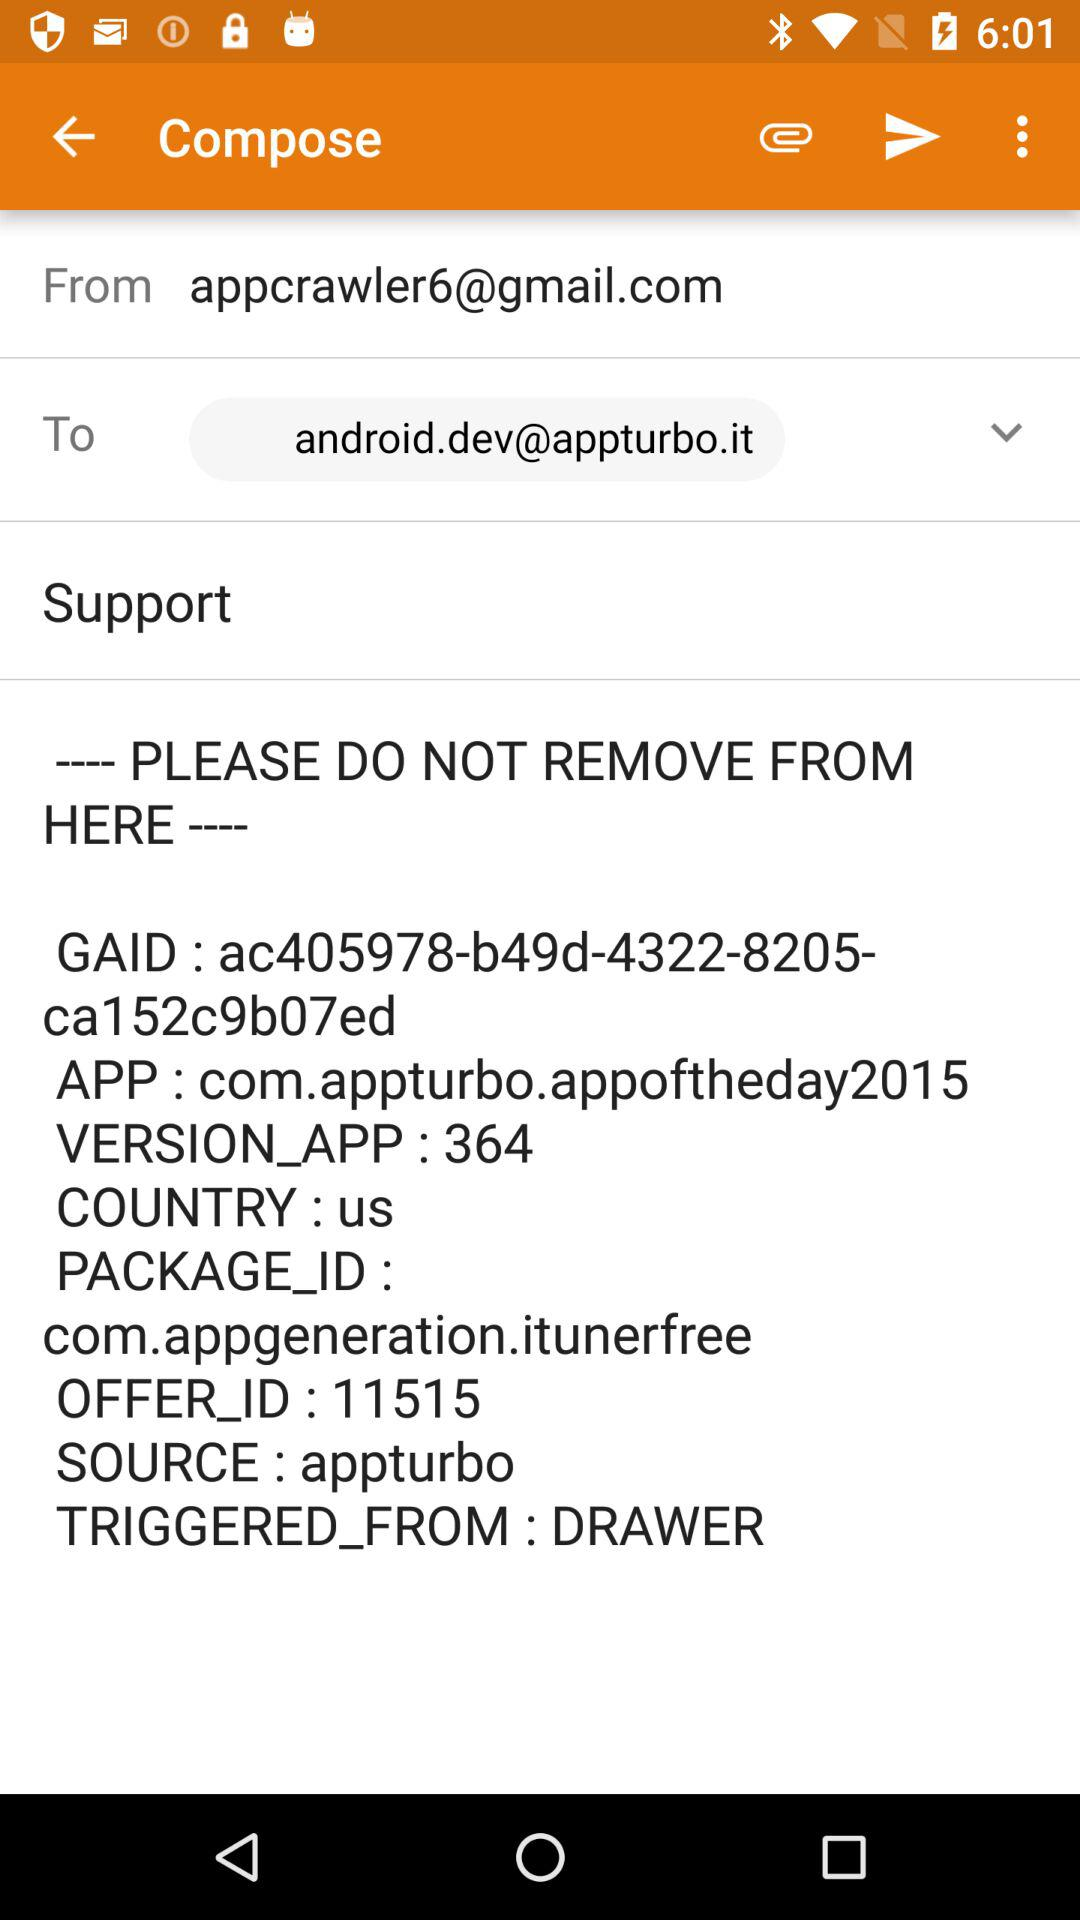What is the source? The source is "appturbo". 